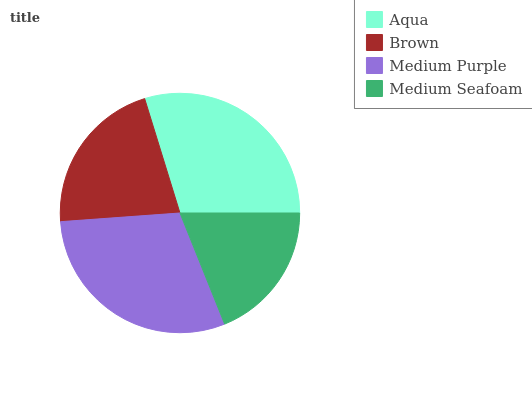Is Medium Seafoam the minimum?
Answer yes or no. Yes. Is Medium Purple the maximum?
Answer yes or no. Yes. Is Brown the minimum?
Answer yes or no. No. Is Brown the maximum?
Answer yes or no. No. Is Aqua greater than Brown?
Answer yes or no. Yes. Is Brown less than Aqua?
Answer yes or no. Yes. Is Brown greater than Aqua?
Answer yes or no. No. Is Aqua less than Brown?
Answer yes or no. No. Is Aqua the high median?
Answer yes or no. Yes. Is Brown the low median?
Answer yes or no. Yes. Is Medium Seafoam the high median?
Answer yes or no. No. Is Medium Purple the low median?
Answer yes or no. No. 